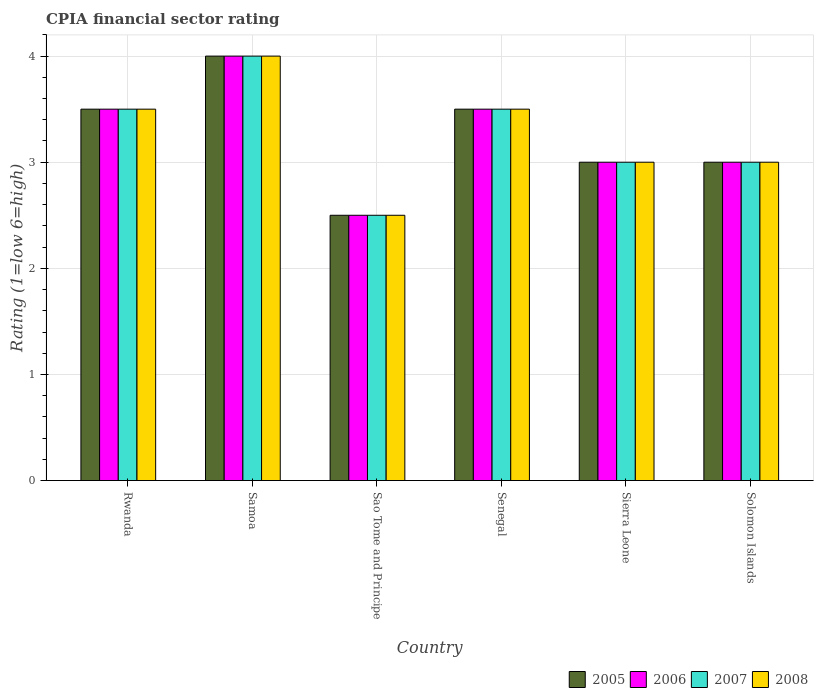How many groups of bars are there?
Offer a terse response. 6. Are the number of bars on each tick of the X-axis equal?
Provide a succinct answer. Yes. How many bars are there on the 5th tick from the right?
Offer a terse response. 4. What is the label of the 6th group of bars from the left?
Offer a terse response. Solomon Islands. What is the CPIA rating in 2007 in Rwanda?
Provide a succinct answer. 3.5. Across all countries, what is the minimum CPIA rating in 2007?
Offer a very short reply. 2.5. In which country was the CPIA rating in 2005 maximum?
Ensure brevity in your answer.  Samoa. In which country was the CPIA rating in 2005 minimum?
Your answer should be compact. Sao Tome and Principe. What is the difference between the CPIA rating in 2008 in Samoa and that in Senegal?
Ensure brevity in your answer.  0.5. What is the difference between the CPIA rating in 2006 in Sierra Leone and the CPIA rating in 2005 in Senegal?
Keep it short and to the point. -0.5. Is the CPIA rating in 2008 in Sao Tome and Principe less than that in Sierra Leone?
Your response must be concise. Yes. Is the difference between the CPIA rating in 2007 in Sao Tome and Principe and Solomon Islands greater than the difference between the CPIA rating in 2006 in Sao Tome and Principe and Solomon Islands?
Offer a very short reply. No. What is the difference between the highest and the second highest CPIA rating in 2008?
Provide a succinct answer. -0.5. What is the difference between the highest and the lowest CPIA rating in 2005?
Offer a very short reply. 1.5. Is the sum of the CPIA rating in 2007 in Rwanda and Sao Tome and Principe greater than the maximum CPIA rating in 2006 across all countries?
Provide a short and direct response. Yes. How many bars are there?
Provide a short and direct response. 24. Does the graph contain any zero values?
Provide a short and direct response. No. What is the title of the graph?
Offer a terse response. CPIA financial sector rating. Does "1991" appear as one of the legend labels in the graph?
Give a very brief answer. No. What is the Rating (1=low 6=high) of 2005 in Rwanda?
Keep it short and to the point. 3.5. What is the Rating (1=low 6=high) of 2007 in Rwanda?
Your answer should be compact. 3.5. What is the Rating (1=low 6=high) of 2008 in Rwanda?
Provide a short and direct response. 3.5. What is the Rating (1=low 6=high) in 2006 in Samoa?
Offer a very short reply. 4. What is the Rating (1=low 6=high) of 2005 in Sao Tome and Principe?
Ensure brevity in your answer.  2.5. What is the Rating (1=low 6=high) of 2006 in Sao Tome and Principe?
Make the answer very short. 2.5. What is the Rating (1=low 6=high) of 2008 in Sao Tome and Principe?
Provide a short and direct response. 2.5. What is the Rating (1=low 6=high) of 2005 in Senegal?
Make the answer very short. 3.5. What is the Rating (1=low 6=high) of 2006 in Senegal?
Your answer should be very brief. 3.5. What is the Rating (1=low 6=high) in 2005 in Sierra Leone?
Offer a very short reply. 3. What is the Rating (1=low 6=high) in 2005 in Solomon Islands?
Ensure brevity in your answer.  3. What is the Rating (1=low 6=high) of 2006 in Solomon Islands?
Offer a very short reply. 3. What is the Rating (1=low 6=high) of 2007 in Solomon Islands?
Your answer should be very brief. 3. Across all countries, what is the maximum Rating (1=low 6=high) of 2006?
Ensure brevity in your answer.  4. Across all countries, what is the maximum Rating (1=low 6=high) of 2008?
Keep it short and to the point. 4. Across all countries, what is the minimum Rating (1=low 6=high) of 2006?
Your answer should be very brief. 2.5. Across all countries, what is the minimum Rating (1=low 6=high) in 2007?
Make the answer very short. 2.5. Across all countries, what is the minimum Rating (1=low 6=high) of 2008?
Your answer should be compact. 2.5. What is the total Rating (1=low 6=high) in 2005 in the graph?
Your answer should be very brief. 19.5. What is the total Rating (1=low 6=high) in 2006 in the graph?
Your answer should be very brief. 19.5. What is the total Rating (1=low 6=high) of 2008 in the graph?
Make the answer very short. 19.5. What is the difference between the Rating (1=low 6=high) in 2005 in Rwanda and that in Samoa?
Your answer should be compact. -0.5. What is the difference between the Rating (1=low 6=high) of 2006 in Rwanda and that in Samoa?
Provide a short and direct response. -0.5. What is the difference between the Rating (1=low 6=high) in 2008 in Rwanda and that in Samoa?
Make the answer very short. -0.5. What is the difference between the Rating (1=low 6=high) in 2008 in Rwanda and that in Sao Tome and Principe?
Make the answer very short. 1. What is the difference between the Rating (1=low 6=high) in 2007 in Rwanda and that in Senegal?
Make the answer very short. 0. What is the difference between the Rating (1=low 6=high) in 2008 in Rwanda and that in Senegal?
Your response must be concise. 0. What is the difference between the Rating (1=low 6=high) of 2005 in Rwanda and that in Sierra Leone?
Make the answer very short. 0.5. What is the difference between the Rating (1=low 6=high) of 2007 in Rwanda and that in Sierra Leone?
Offer a terse response. 0.5. What is the difference between the Rating (1=low 6=high) of 2008 in Rwanda and that in Sierra Leone?
Provide a succinct answer. 0.5. What is the difference between the Rating (1=low 6=high) of 2005 in Rwanda and that in Solomon Islands?
Your answer should be compact. 0.5. What is the difference between the Rating (1=low 6=high) of 2007 in Rwanda and that in Solomon Islands?
Make the answer very short. 0.5. What is the difference between the Rating (1=low 6=high) in 2006 in Samoa and that in Sao Tome and Principe?
Offer a very short reply. 1.5. What is the difference between the Rating (1=low 6=high) in 2006 in Samoa and that in Senegal?
Provide a succinct answer. 0.5. What is the difference between the Rating (1=low 6=high) in 2008 in Samoa and that in Senegal?
Make the answer very short. 0.5. What is the difference between the Rating (1=low 6=high) in 2005 in Samoa and that in Sierra Leone?
Provide a succinct answer. 1. What is the difference between the Rating (1=low 6=high) of 2006 in Samoa and that in Sierra Leone?
Your response must be concise. 1. What is the difference between the Rating (1=low 6=high) of 2007 in Samoa and that in Sierra Leone?
Give a very brief answer. 1. What is the difference between the Rating (1=low 6=high) of 2008 in Samoa and that in Sierra Leone?
Your answer should be very brief. 1. What is the difference between the Rating (1=low 6=high) in 2008 in Samoa and that in Solomon Islands?
Your answer should be compact. 1. What is the difference between the Rating (1=low 6=high) of 2005 in Sao Tome and Principe and that in Senegal?
Keep it short and to the point. -1. What is the difference between the Rating (1=low 6=high) of 2006 in Sao Tome and Principe and that in Senegal?
Your answer should be compact. -1. What is the difference between the Rating (1=low 6=high) in 2008 in Sao Tome and Principe and that in Senegal?
Make the answer very short. -1. What is the difference between the Rating (1=low 6=high) of 2005 in Sao Tome and Principe and that in Sierra Leone?
Your answer should be compact. -0.5. What is the difference between the Rating (1=low 6=high) in 2006 in Sao Tome and Principe and that in Sierra Leone?
Provide a short and direct response. -0.5. What is the difference between the Rating (1=low 6=high) of 2007 in Sao Tome and Principe and that in Sierra Leone?
Your answer should be very brief. -0.5. What is the difference between the Rating (1=low 6=high) in 2008 in Sao Tome and Principe and that in Solomon Islands?
Offer a very short reply. -0.5. What is the difference between the Rating (1=low 6=high) in 2005 in Senegal and that in Sierra Leone?
Offer a terse response. 0.5. What is the difference between the Rating (1=low 6=high) in 2006 in Senegal and that in Sierra Leone?
Give a very brief answer. 0.5. What is the difference between the Rating (1=low 6=high) in 2008 in Senegal and that in Sierra Leone?
Provide a short and direct response. 0.5. What is the difference between the Rating (1=low 6=high) of 2005 in Senegal and that in Solomon Islands?
Provide a succinct answer. 0.5. What is the difference between the Rating (1=low 6=high) in 2006 in Senegal and that in Solomon Islands?
Your answer should be very brief. 0.5. What is the difference between the Rating (1=low 6=high) in 2006 in Sierra Leone and that in Solomon Islands?
Your answer should be compact. 0. What is the difference between the Rating (1=low 6=high) of 2007 in Sierra Leone and that in Solomon Islands?
Give a very brief answer. 0. What is the difference between the Rating (1=low 6=high) of 2008 in Sierra Leone and that in Solomon Islands?
Provide a short and direct response. 0. What is the difference between the Rating (1=low 6=high) of 2005 in Rwanda and the Rating (1=low 6=high) of 2007 in Samoa?
Provide a short and direct response. -0.5. What is the difference between the Rating (1=low 6=high) in 2005 in Rwanda and the Rating (1=low 6=high) in 2008 in Samoa?
Offer a very short reply. -0.5. What is the difference between the Rating (1=low 6=high) in 2006 in Rwanda and the Rating (1=low 6=high) in 2007 in Samoa?
Keep it short and to the point. -0.5. What is the difference between the Rating (1=low 6=high) in 2006 in Rwanda and the Rating (1=low 6=high) in 2008 in Samoa?
Offer a terse response. -0.5. What is the difference between the Rating (1=low 6=high) in 2005 in Rwanda and the Rating (1=low 6=high) in 2006 in Sao Tome and Principe?
Ensure brevity in your answer.  1. What is the difference between the Rating (1=low 6=high) of 2005 in Rwanda and the Rating (1=low 6=high) of 2008 in Sao Tome and Principe?
Provide a succinct answer. 1. What is the difference between the Rating (1=low 6=high) in 2006 in Rwanda and the Rating (1=low 6=high) in 2008 in Sao Tome and Principe?
Your answer should be compact. 1. What is the difference between the Rating (1=low 6=high) in 2007 in Rwanda and the Rating (1=low 6=high) in 2008 in Sao Tome and Principe?
Your answer should be compact. 1. What is the difference between the Rating (1=low 6=high) in 2005 in Rwanda and the Rating (1=low 6=high) in 2006 in Senegal?
Provide a short and direct response. 0. What is the difference between the Rating (1=low 6=high) of 2005 in Rwanda and the Rating (1=low 6=high) of 2007 in Senegal?
Provide a succinct answer. 0. What is the difference between the Rating (1=low 6=high) in 2005 in Rwanda and the Rating (1=low 6=high) in 2006 in Sierra Leone?
Your response must be concise. 0.5. What is the difference between the Rating (1=low 6=high) in 2005 in Rwanda and the Rating (1=low 6=high) in 2008 in Sierra Leone?
Offer a terse response. 0.5. What is the difference between the Rating (1=low 6=high) in 2006 in Rwanda and the Rating (1=low 6=high) in 2007 in Sierra Leone?
Provide a short and direct response. 0.5. What is the difference between the Rating (1=low 6=high) of 2006 in Rwanda and the Rating (1=low 6=high) of 2008 in Sierra Leone?
Your answer should be compact. 0.5. What is the difference between the Rating (1=low 6=high) of 2007 in Rwanda and the Rating (1=low 6=high) of 2008 in Sierra Leone?
Provide a short and direct response. 0.5. What is the difference between the Rating (1=low 6=high) of 2005 in Rwanda and the Rating (1=low 6=high) of 2006 in Solomon Islands?
Make the answer very short. 0.5. What is the difference between the Rating (1=low 6=high) of 2005 in Rwanda and the Rating (1=low 6=high) of 2008 in Solomon Islands?
Your response must be concise. 0.5. What is the difference between the Rating (1=low 6=high) of 2006 in Rwanda and the Rating (1=low 6=high) of 2007 in Solomon Islands?
Your response must be concise. 0.5. What is the difference between the Rating (1=low 6=high) of 2006 in Rwanda and the Rating (1=low 6=high) of 2008 in Solomon Islands?
Ensure brevity in your answer.  0.5. What is the difference between the Rating (1=low 6=high) in 2007 in Rwanda and the Rating (1=low 6=high) in 2008 in Solomon Islands?
Your answer should be very brief. 0.5. What is the difference between the Rating (1=low 6=high) of 2005 in Samoa and the Rating (1=low 6=high) of 2006 in Sao Tome and Principe?
Ensure brevity in your answer.  1.5. What is the difference between the Rating (1=low 6=high) in 2005 in Samoa and the Rating (1=low 6=high) in 2007 in Sao Tome and Principe?
Offer a very short reply. 1.5. What is the difference between the Rating (1=low 6=high) in 2006 in Samoa and the Rating (1=low 6=high) in 2007 in Sao Tome and Principe?
Provide a short and direct response. 1.5. What is the difference between the Rating (1=low 6=high) in 2007 in Samoa and the Rating (1=low 6=high) in 2008 in Sao Tome and Principe?
Offer a terse response. 1.5. What is the difference between the Rating (1=low 6=high) of 2005 in Samoa and the Rating (1=low 6=high) of 2006 in Senegal?
Offer a terse response. 0.5. What is the difference between the Rating (1=low 6=high) of 2005 in Samoa and the Rating (1=low 6=high) of 2007 in Senegal?
Give a very brief answer. 0.5. What is the difference between the Rating (1=low 6=high) in 2005 in Samoa and the Rating (1=low 6=high) in 2008 in Senegal?
Give a very brief answer. 0.5. What is the difference between the Rating (1=low 6=high) in 2006 in Samoa and the Rating (1=low 6=high) in 2007 in Senegal?
Your response must be concise. 0.5. What is the difference between the Rating (1=low 6=high) in 2005 in Samoa and the Rating (1=low 6=high) in 2006 in Sierra Leone?
Ensure brevity in your answer.  1. What is the difference between the Rating (1=low 6=high) of 2005 in Samoa and the Rating (1=low 6=high) of 2007 in Sierra Leone?
Your answer should be very brief. 1. What is the difference between the Rating (1=low 6=high) of 2005 in Samoa and the Rating (1=low 6=high) of 2008 in Sierra Leone?
Give a very brief answer. 1. What is the difference between the Rating (1=low 6=high) of 2006 in Samoa and the Rating (1=low 6=high) of 2008 in Sierra Leone?
Keep it short and to the point. 1. What is the difference between the Rating (1=low 6=high) of 2005 in Samoa and the Rating (1=low 6=high) of 2006 in Solomon Islands?
Keep it short and to the point. 1. What is the difference between the Rating (1=low 6=high) in 2005 in Samoa and the Rating (1=low 6=high) in 2007 in Solomon Islands?
Give a very brief answer. 1. What is the difference between the Rating (1=low 6=high) in 2005 in Sao Tome and Principe and the Rating (1=low 6=high) in 2008 in Senegal?
Your answer should be compact. -1. What is the difference between the Rating (1=low 6=high) in 2007 in Sao Tome and Principe and the Rating (1=low 6=high) in 2008 in Senegal?
Your answer should be very brief. -1. What is the difference between the Rating (1=low 6=high) in 2006 in Sao Tome and Principe and the Rating (1=low 6=high) in 2007 in Sierra Leone?
Make the answer very short. -0.5. What is the difference between the Rating (1=low 6=high) in 2006 in Sao Tome and Principe and the Rating (1=low 6=high) in 2008 in Sierra Leone?
Your response must be concise. -0.5. What is the difference between the Rating (1=low 6=high) of 2005 in Sao Tome and Principe and the Rating (1=low 6=high) of 2006 in Solomon Islands?
Provide a succinct answer. -0.5. What is the difference between the Rating (1=low 6=high) in 2005 in Sao Tome and Principe and the Rating (1=low 6=high) in 2008 in Solomon Islands?
Give a very brief answer. -0.5. What is the difference between the Rating (1=low 6=high) in 2006 in Sao Tome and Principe and the Rating (1=low 6=high) in 2008 in Solomon Islands?
Offer a terse response. -0.5. What is the difference between the Rating (1=low 6=high) in 2007 in Sao Tome and Principe and the Rating (1=low 6=high) in 2008 in Solomon Islands?
Keep it short and to the point. -0.5. What is the difference between the Rating (1=low 6=high) of 2005 in Senegal and the Rating (1=low 6=high) of 2006 in Sierra Leone?
Your response must be concise. 0.5. What is the difference between the Rating (1=low 6=high) in 2005 in Senegal and the Rating (1=low 6=high) in 2008 in Sierra Leone?
Give a very brief answer. 0.5. What is the difference between the Rating (1=low 6=high) of 2006 in Senegal and the Rating (1=low 6=high) of 2007 in Sierra Leone?
Offer a very short reply. 0.5. What is the difference between the Rating (1=low 6=high) of 2005 in Senegal and the Rating (1=low 6=high) of 2008 in Solomon Islands?
Offer a terse response. 0.5. What is the difference between the Rating (1=low 6=high) in 2006 in Senegal and the Rating (1=low 6=high) in 2007 in Solomon Islands?
Your response must be concise. 0.5. What is the difference between the Rating (1=low 6=high) of 2007 in Senegal and the Rating (1=low 6=high) of 2008 in Solomon Islands?
Ensure brevity in your answer.  0.5. What is the difference between the Rating (1=low 6=high) of 2005 in Sierra Leone and the Rating (1=low 6=high) of 2008 in Solomon Islands?
Your response must be concise. 0. What is the difference between the Rating (1=low 6=high) of 2007 in Sierra Leone and the Rating (1=low 6=high) of 2008 in Solomon Islands?
Ensure brevity in your answer.  0. What is the average Rating (1=low 6=high) of 2007 per country?
Your answer should be compact. 3.25. What is the difference between the Rating (1=low 6=high) of 2005 and Rating (1=low 6=high) of 2007 in Rwanda?
Make the answer very short. 0. What is the difference between the Rating (1=low 6=high) in 2005 and Rating (1=low 6=high) in 2008 in Rwanda?
Your answer should be very brief. 0. What is the difference between the Rating (1=low 6=high) of 2006 and Rating (1=low 6=high) of 2008 in Rwanda?
Make the answer very short. 0. What is the difference between the Rating (1=low 6=high) in 2005 and Rating (1=low 6=high) in 2007 in Samoa?
Offer a terse response. 0. What is the difference between the Rating (1=low 6=high) of 2005 and Rating (1=low 6=high) of 2008 in Samoa?
Make the answer very short. 0. What is the difference between the Rating (1=low 6=high) of 2007 and Rating (1=low 6=high) of 2008 in Samoa?
Give a very brief answer. 0. What is the difference between the Rating (1=low 6=high) in 2006 and Rating (1=low 6=high) in 2008 in Sao Tome and Principe?
Provide a succinct answer. 0. What is the difference between the Rating (1=low 6=high) in 2007 and Rating (1=low 6=high) in 2008 in Sao Tome and Principe?
Make the answer very short. 0. What is the difference between the Rating (1=low 6=high) in 2005 and Rating (1=low 6=high) in 2006 in Senegal?
Your answer should be compact. 0. What is the difference between the Rating (1=low 6=high) of 2005 and Rating (1=low 6=high) of 2008 in Senegal?
Provide a short and direct response. 0. What is the difference between the Rating (1=low 6=high) in 2006 and Rating (1=low 6=high) in 2007 in Senegal?
Give a very brief answer. 0. What is the difference between the Rating (1=low 6=high) in 2007 and Rating (1=low 6=high) in 2008 in Senegal?
Give a very brief answer. 0. What is the difference between the Rating (1=low 6=high) of 2005 and Rating (1=low 6=high) of 2006 in Sierra Leone?
Make the answer very short. 0. What is the difference between the Rating (1=low 6=high) of 2005 and Rating (1=low 6=high) of 2008 in Sierra Leone?
Keep it short and to the point. 0. What is the difference between the Rating (1=low 6=high) of 2007 and Rating (1=low 6=high) of 2008 in Sierra Leone?
Provide a short and direct response. 0. What is the difference between the Rating (1=low 6=high) of 2005 and Rating (1=low 6=high) of 2006 in Solomon Islands?
Your response must be concise. 0. What is the difference between the Rating (1=low 6=high) in 2005 and Rating (1=low 6=high) in 2007 in Solomon Islands?
Your answer should be compact. 0. What is the difference between the Rating (1=low 6=high) of 2006 and Rating (1=low 6=high) of 2007 in Solomon Islands?
Provide a succinct answer. 0. What is the difference between the Rating (1=low 6=high) in 2006 and Rating (1=low 6=high) in 2008 in Solomon Islands?
Offer a very short reply. 0. What is the difference between the Rating (1=low 6=high) in 2007 and Rating (1=low 6=high) in 2008 in Solomon Islands?
Offer a very short reply. 0. What is the ratio of the Rating (1=low 6=high) of 2008 in Rwanda to that in Samoa?
Ensure brevity in your answer.  0.88. What is the ratio of the Rating (1=low 6=high) of 2005 in Rwanda to that in Sao Tome and Principe?
Ensure brevity in your answer.  1.4. What is the ratio of the Rating (1=low 6=high) in 2006 in Rwanda to that in Sao Tome and Principe?
Your answer should be very brief. 1.4. What is the ratio of the Rating (1=low 6=high) in 2007 in Rwanda to that in Sao Tome and Principe?
Your answer should be compact. 1.4. What is the ratio of the Rating (1=low 6=high) in 2008 in Rwanda to that in Sao Tome and Principe?
Your answer should be very brief. 1.4. What is the ratio of the Rating (1=low 6=high) in 2005 in Rwanda to that in Senegal?
Offer a very short reply. 1. What is the ratio of the Rating (1=low 6=high) in 2006 in Rwanda to that in Senegal?
Offer a very short reply. 1. What is the ratio of the Rating (1=low 6=high) of 2008 in Rwanda to that in Sierra Leone?
Make the answer very short. 1.17. What is the ratio of the Rating (1=low 6=high) in 2005 in Rwanda to that in Solomon Islands?
Provide a succinct answer. 1.17. What is the ratio of the Rating (1=low 6=high) of 2006 in Rwanda to that in Solomon Islands?
Your response must be concise. 1.17. What is the ratio of the Rating (1=low 6=high) of 2007 in Rwanda to that in Solomon Islands?
Ensure brevity in your answer.  1.17. What is the ratio of the Rating (1=low 6=high) of 2008 in Rwanda to that in Solomon Islands?
Ensure brevity in your answer.  1.17. What is the ratio of the Rating (1=low 6=high) of 2005 in Samoa to that in Sao Tome and Principe?
Give a very brief answer. 1.6. What is the ratio of the Rating (1=low 6=high) in 2007 in Samoa to that in Sao Tome and Principe?
Offer a terse response. 1.6. What is the ratio of the Rating (1=low 6=high) in 2005 in Samoa to that in Senegal?
Make the answer very short. 1.14. What is the ratio of the Rating (1=low 6=high) in 2008 in Samoa to that in Senegal?
Your response must be concise. 1.14. What is the ratio of the Rating (1=low 6=high) of 2008 in Samoa to that in Sierra Leone?
Your answer should be very brief. 1.33. What is the ratio of the Rating (1=low 6=high) in 2006 in Samoa to that in Solomon Islands?
Provide a short and direct response. 1.33. What is the ratio of the Rating (1=low 6=high) of 2007 in Samoa to that in Solomon Islands?
Keep it short and to the point. 1.33. What is the ratio of the Rating (1=low 6=high) of 2008 in Samoa to that in Solomon Islands?
Your answer should be very brief. 1.33. What is the ratio of the Rating (1=low 6=high) of 2005 in Sao Tome and Principe to that in Senegal?
Keep it short and to the point. 0.71. What is the ratio of the Rating (1=low 6=high) of 2005 in Sao Tome and Principe to that in Sierra Leone?
Keep it short and to the point. 0.83. What is the ratio of the Rating (1=low 6=high) of 2007 in Sao Tome and Principe to that in Sierra Leone?
Offer a terse response. 0.83. What is the ratio of the Rating (1=low 6=high) of 2008 in Sao Tome and Principe to that in Sierra Leone?
Keep it short and to the point. 0.83. What is the ratio of the Rating (1=low 6=high) in 2007 in Sao Tome and Principe to that in Solomon Islands?
Your response must be concise. 0.83. What is the ratio of the Rating (1=low 6=high) of 2005 in Senegal to that in Sierra Leone?
Ensure brevity in your answer.  1.17. What is the ratio of the Rating (1=low 6=high) in 2007 in Senegal to that in Sierra Leone?
Your answer should be compact. 1.17. What is the ratio of the Rating (1=low 6=high) in 2007 in Senegal to that in Solomon Islands?
Give a very brief answer. 1.17. What is the ratio of the Rating (1=low 6=high) in 2006 in Sierra Leone to that in Solomon Islands?
Make the answer very short. 1. What is the ratio of the Rating (1=low 6=high) in 2007 in Sierra Leone to that in Solomon Islands?
Provide a short and direct response. 1. What is the difference between the highest and the second highest Rating (1=low 6=high) of 2005?
Make the answer very short. 0.5. What is the difference between the highest and the second highest Rating (1=low 6=high) of 2006?
Offer a very short reply. 0.5. What is the difference between the highest and the second highest Rating (1=low 6=high) in 2008?
Give a very brief answer. 0.5. What is the difference between the highest and the lowest Rating (1=low 6=high) of 2005?
Your answer should be compact. 1.5. What is the difference between the highest and the lowest Rating (1=low 6=high) in 2006?
Give a very brief answer. 1.5. What is the difference between the highest and the lowest Rating (1=low 6=high) in 2008?
Your answer should be very brief. 1.5. 